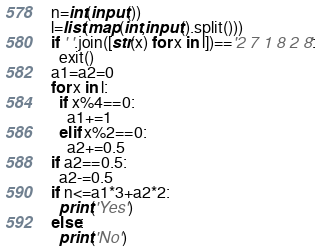<code> <loc_0><loc_0><loc_500><loc_500><_Python_>n=int(input())
l=list(map(int,input().split()))
if ' '.join([str(x) for x in l])=='2 7 1 8 2 8':
  exit()
a1=a2=0
for x in l:
  if x%4==0:
    a1+=1
  elif x%2==0:
    a2+=0.5
if a2==0.5:
  a2-=0.5
if n<=a1*3+a2*2:
  print('Yes')
else:
  print('No')</code> 